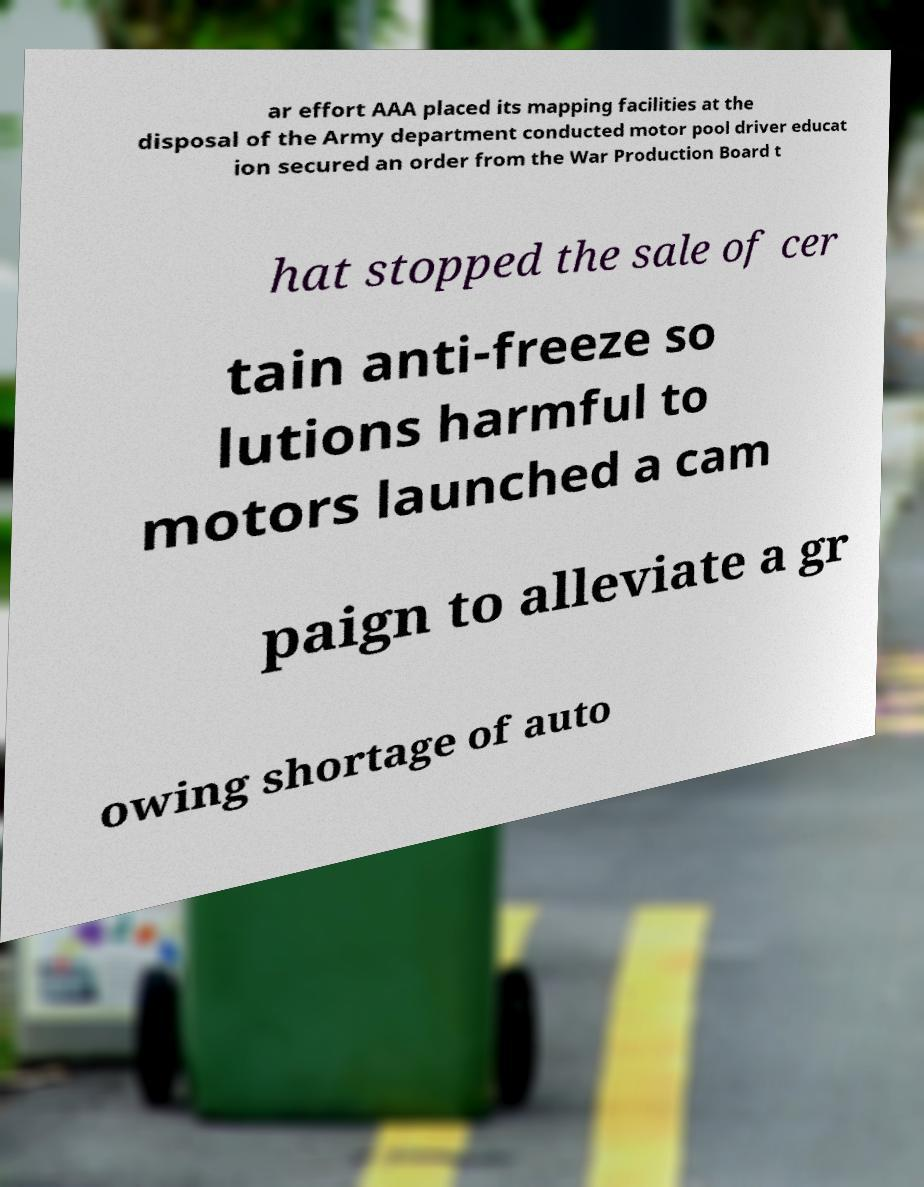For documentation purposes, I need the text within this image transcribed. Could you provide that? ar effort AAA placed its mapping facilities at the disposal of the Army department conducted motor pool driver educat ion secured an order from the War Production Board t hat stopped the sale of cer tain anti-freeze so lutions harmful to motors launched a cam paign to alleviate a gr owing shortage of auto 